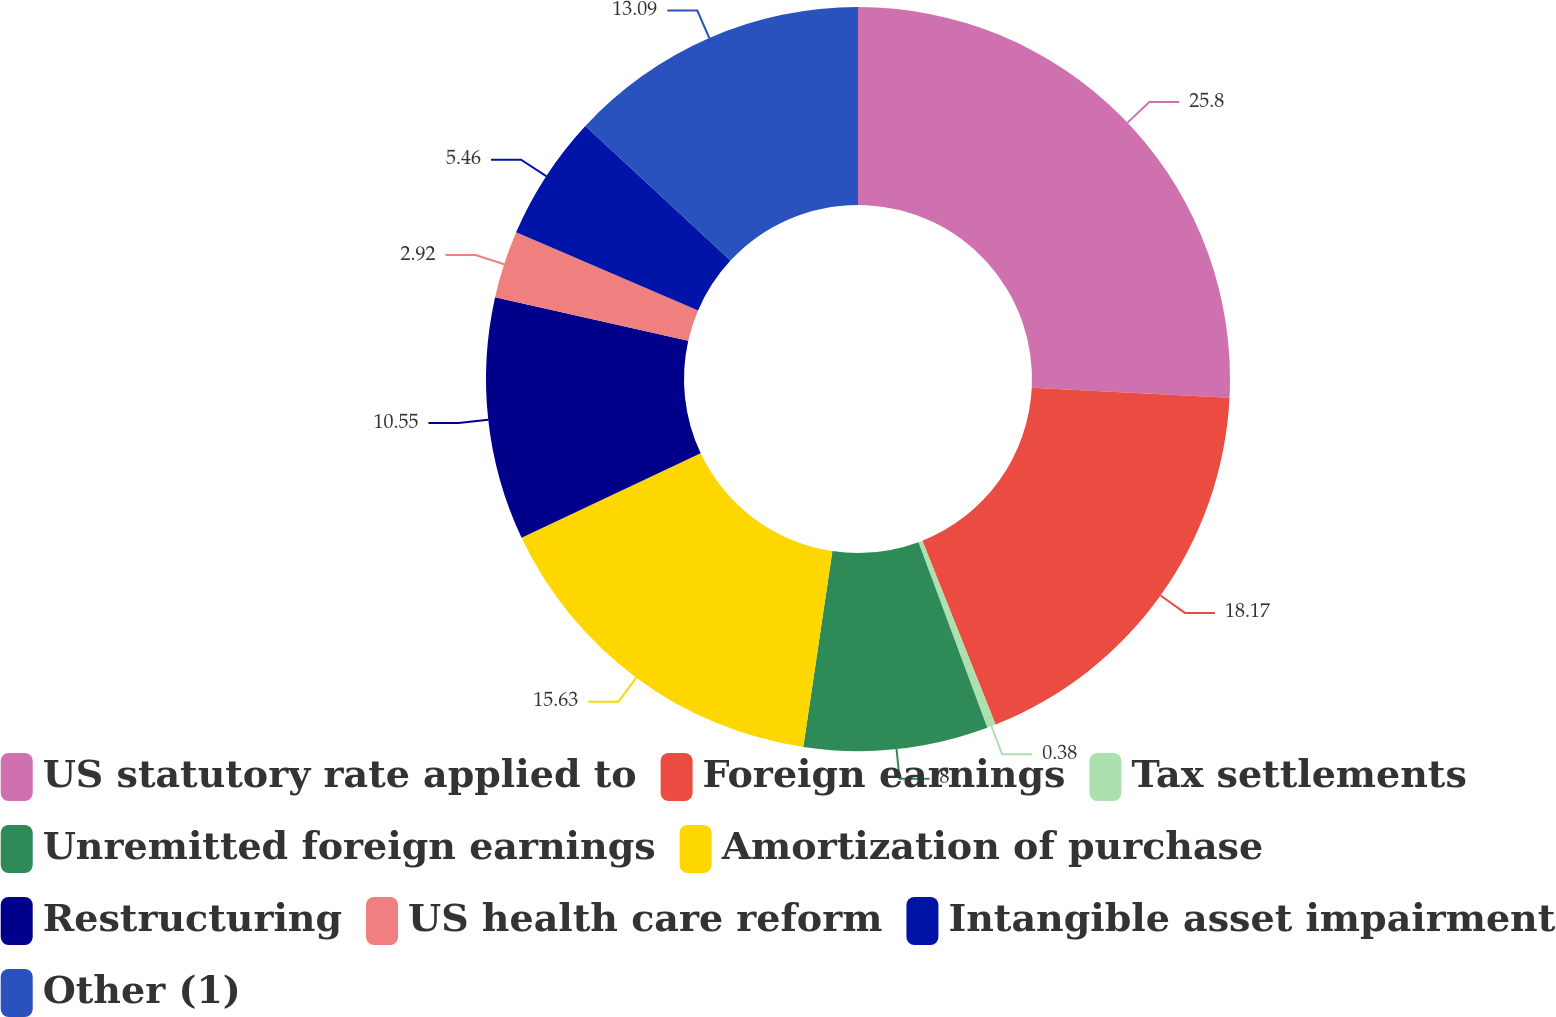<chart> <loc_0><loc_0><loc_500><loc_500><pie_chart><fcel>US statutory rate applied to<fcel>Foreign earnings<fcel>Tax settlements<fcel>Unremitted foreign earnings<fcel>Amortization of purchase<fcel>Restructuring<fcel>US health care reform<fcel>Intangible asset impairment<fcel>Other (1)<nl><fcel>25.8%<fcel>18.17%<fcel>0.38%<fcel>8.0%<fcel>15.63%<fcel>10.55%<fcel>2.92%<fcel>5.46%<fcel>13.09%<nl></chart> 